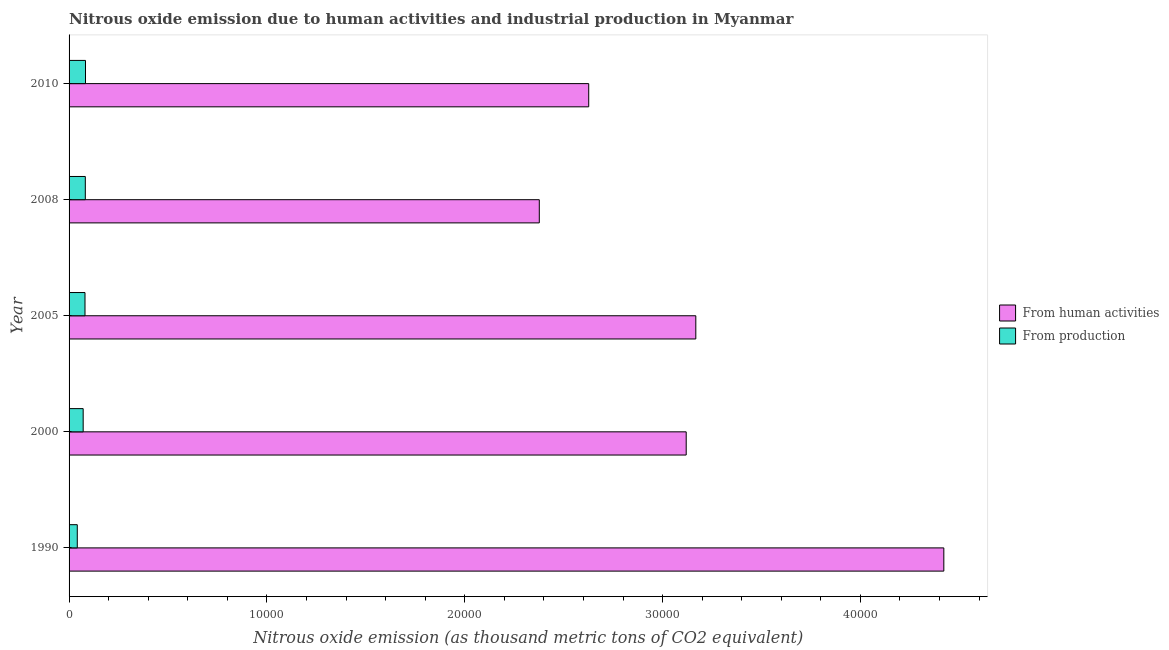Are the number of bars on each tick of the Y-axis equal?
Your response must be concise. Yes. How many bars are there on the 3rd tick from the top?
Offer a terse response. 2. How many bars are there on the 4th tick from the bottom?
Provide a succinct answer. 2. In how many cases, is the number of bars for a given year not equal to the number of legend labels?
Give a very brief answer. 0. What is the amount of emissions generated from industries in 2010?
Keep it short and to the point. 830.8. Across all years, what is the maximum amount of emissions generated from industries?
Your answer should be compact. 830.8. Across all years, what is the minimum amount of emissions from human activities?
Provide a succinct answer. 2.38e+04. What is the total amount of emissions from human activities in the graph?
Provide a succinct answer. 1.57e+05. What is the difference between the amount of emissions generated from industries in 2000 and that in 2010?
Your answer should be compact. -117.7. What is the difference between the amount of emissions generated from industries in 2000 and the amount of emissions from human activities in 2010?
Give a very brief answer. -2.56e+04. What is the average amount of emissions from human activities per year?
Keep it short and to the point. 3.14e+04. In the year 2008, what is the difference between the amount of emissions generated from industries and amount of emissions from human activities?
Make the answer very short. -2.29e+04. What is the ratio of the amount of emissions generated from industries in 1990 to that in 2008?
Provide a succinct answer. 0.51. Is the amount of emissions generated from industries in 2000 less than that in 2010?
Offer a terse response. Yes. What is the difference between the highest and the second highest amount of emissions from human activities?
Provide a short and direct response. 1.25e+04. What is the difference between the highest and the lowest amount of emissions from human activities?
Your answer should be very brief. 2.04e+04. In how many years, is the amount of emissions from human activities greater than the average amount of emissions from human activities taken over all years?
Ensure brevity in your answer.  2. What does the 2nd bar from the top in 2008 represents?
Your response must be concise. From human activities. What does the 2nd bar from the bottom in 2000 represents?
Offer a terse response. From production. How many bars are there?
Your answer should be compact. 10. Are all the bars in the graph horizontal?
Your answer should be very brief. Yes. How many years are there in the graph?
Your response must be concise. 5. What is the difference between two consecutive major ticks on the X-axis?
Make the answer very short. 10000. Does the graph contain grids?
Your answer should be compact. No. How many legend labels are there?
Provide a succinct answer. 2. How are the legend labels stacked?
Provide a succinct answer. Vertical. What is the title of the graph?
Provide a succinct answer. Nitrous oxide emission due to human activities and industrial production in Myanmar. What is the label or title of the X-axis?
Provide a short and direct response. Nitrous oxide emission (as thousand metric tons of CO2 equivalent). What is the label or title of the Y-axis?
Provide a succinct answer. Year. What is the Nitrous oxide emission (as thousand metric tons of CO2 equivalent) of From human activities in 1990?
Give a very brief answer. 4.42e+04. What is the Nitrous oxide emission (as thousand metric tons of CO2 equivalent) in From production in 1990?
Give a very brief answer. 414.7. What is the Nitrous oxide emission (as thousand metric tons of CO2 equivalent) in From human activities in 2000?
Give a very brief answer. 3.12e+04. What is the Nitrous oxide emission (as thousand metric tons of CO2 equivalent) in From production in 2000?
Offer a very short reply. 713.1. What is the Nitrous oxide emission (as thousand metric tons of CO2 equivalent) in From human activities in 2005?
Your answer should be compact. 3.17e+04. What is the Nitrous oxide emission (as thousand metric tons of CO2 equivalent) in From production in 2005?
Your response must be concise. 804.8. What is the Nitrous oxide emission (as thousand metric tons of CO2 equivalent) in From human activities in 2008?
Offer a very short reply. 2.38e+04. What is the Nitrous oxide emission (as thousand metric tons of CO2 equivalent) in From production in 2008?
Your answer should be very brief. 821.1. What is the Nitrous oxide emission (as thousand metric tons of CO2 equivalent) in From human activities in 2010?
Your answer should be compact. 2.63e+04. What is the Nitrous oxide emission (as thousand metric tons of CO2 equivalent) in From production in 2010?
Make the answer very short. 830.8. Across all years, what is the maximum Nitrous oxide emission (as thousand metric tons of CO2 equivalent) of From human activities?
Provide a succinct answer. 4.42e+04. Across all years, what is the maximum Nitrous oxide emission (as thousand metric tons of CO2 equivalent) of From production?
Give a very brief answer. 830.8. Across all years, what is the minimum Nitrous oxide emission (as thousand metric tons of CO2 equivalent) of From human activities?
Offer a terse response. 2.38e+04. Across all years, what is the minimum Nitrous oxide emission (as thousand metric tons of CO2 equivalent) of From production?
Ensure brevity in your answer.  414.7. What is the total Nitrous oxide emission (as thousand metric tons of CO2 equivalent) in From human activities in the graph?
Keep it short and to the point. 1.57e+05. What is the total Nitrous oxide emission (as thousand metric tons of CO2 equivalent) in From production in the graph?
Provide a succinct answer. 3584.5. What is the difference between the Nitrous oxide emission (as thousand metric tons of CO2 equivalent) of From human activities in 1990 and that in 2000?
Ensure brevity in your answer.  1.30e+04. What is the difference between the Nitrous oxide emission (as thousand metric tons of CO2 equivalent) in From production in 1990 and that in 2000?
Offer a very short reply. -298.4. What is the difference between the Nitrous oxide emission (as thousand metric tons of CO2 equivalent) in From human activities in 1990 and that in 2005?
Your answer should be very brief. 1.25e+04. What is the difference between the Nitrous oxide emission (as thousand metric tons of CO2 equivalent) in From production in 1990 and that in 2005?
Provide a succinct answer. -390.1. What is the difference between the Nitrous oxide emission (as thousand metric tons of CO2 equivalent) of From human activities in 1990 and that in 2008?
Ensure brevity in your answer.  2.04e+04. What is the difference between the Nitrous oxide emission (as thousand metric tons of CO2 equivalent) of From production in 1990 and that in 2008?
Give a very brief answer. -406.4. What is the difference between the Nitrous oxide emission (as thousand metric tons of CO2 equivalent) in From human activities in 1990 and that in 2010?
Offer a terse response. 1.80e+04. What is the difference between the Nitrous oxide emission (as thousand metric tons of CO2 equivalent) in From production in 1990 and that in 2010?
Ensure brevity in your answer.  -416.1. What is the difference between the Nitrous oxide emission (as thousand metric tons of CO2 equivalent) of From human activities in 2000 and that in 2005?
Make the answer very short. -485.9. What is the difference between the Nitrous oxide emission (as thousand metric tons of CO2 equivalent) of From production in 2000 and that in 2005?
Your response must be concise. -91.7. What is the difference between the Nitrous oxide emission (as thousand metric tons of CO2 equivalent) of From human activities in 2000 and that in 2008?
Your answer should be very brief. 7425.1. What is the difference between the Nitrous oxide emission (as thousand metric tons of CO2 equivalent) in From production in 2000 and that in 2008?
Give a very brief answer. -108. What is the difference between the Nitrous oxide emission (as thousand metric tons of CO2 equivalent) of From human activities in 2000 and that in 2010?
Your answer should be very brief. 4927.7. What is the difference between the Nitrous oxide emission (as thousand metric tons of CO2 equivalent) of From production in 2000 and that in 2010?
Your response must be concise. -117.7. What is the difference between the Nitrous oxide emission (as thousand metric tons of CO2 equivalent) in From human activities in 2005 and that in 2008?
Your response must be concise. 7911. What is the difference between the Nitrous oxide emission (as thousand metric tons of CO2 equivalent) of From production in 2005 and that in 2008?
Provide a succinct answer. -16.3. What is the difference between the Nitrous oxide emission (as thousand metric tons of CO2 equivalent) in From human activities in 2005 and that in 2010?
Your answer should be very brief. 5413.6. What is the difference between the Nitrous oxide emission (as thousand metric tons of CO2 equivalent) in From production in 2005 and that in 2010?
Give a very brief answer. -26. What is the difference between the Nitrous oxide emission (as thousand metric tons of CO2 equivalent) in From human activities in 2008 and that in 2010?
Your answer should be very brief. -2497.4. What is the difference between the Nitrous oxide emission (as thousand metric tons of CO2 equivalent) in From production in 2008 and that in 2010?
Provide a short and direct response. -9.7. What is the difference between the Nitrous oxide emission (as thousand metric tons of CO2 equivalent) in From human activities in 1990 and the Nitrous oxide emission (as thousand metric tons of CO2 equivalent) in From production in 2000?
Your response must be concise. 4.35e+04. What is the difference between the Nitrous oxide emission (as thousand metric tons of CO2 equivalent) of From human activities in 1990 and the Nitrous oxide emission (as thousand metric tons of CO2 equivalent) of From production in 2005?
Ensure brevity in your answer.  4.34e+04. What is the difference between the Nitrous oxide emission (as thousand metric tons of CO2 equivalent) of From human activities in 1990 and the Nitrous oxide emission (as thousand metric tons of CO2 equivalent) of From production in 2008?
Keep it short and to the point. 4.34e+04. What is the difference between the Nitrous oxide emission (as thousand metric tons of CO2 equivalent) in From human activities in 1990 and the Nitrous oxide emission (as thousand metric tons of CO2 equivalent) in From production in 2010?
Make the answer very short. 4.34e+04. What is the difference between the Nitrous oxide emission (as thousand metric tons of CO2 equivalent) of From human activities in 2000 and the Nitrous oxide emission (as thousand metric tons of CO2 equivalent) of From production in 2005?
Ensure brevity in your answer.  3.04e+04. What is the difference between the Nitrous oxide emission (as thousand metric tons of CO2 equivalent) of From human activities in 2000 and the Nitrous oxide emission (as thousand metric tons of CO2 equivalent) of From production in 2008?
Ensure brevity in your answer.  3.04e+04. What is the difference between the Nitrous oxide emission (as thousand metric tons of CO2 equivalent) in From human activities in 2000 and the Nitrous oxide emission (as thousand metric tons of CO2 equivalent) in From production in 2010?
Provide a succinct answer. 3.04e+04. What is the difference between the Nitrous oxide emission (as thousand metric tons of CO2 equivalent) of From human activities in 2005 and the Nitrous oxide emission (as thousand metric tons of CO2 equivalent) of From production in 2008?
Offer a very short reply. 3.09e+04. What is the difference between the Nitrous oxide emission (as thousand metric tons of CO2 equivalent) of From human activities in 2005 and the Nitrous oxide emission (as thousand metric tons of CO2 equivalent) of From production in 2010?
Provide a short and direct response. 3.08e+04. What is the difference between the Nitrous oxide emission (as thousand metric tons of CO2 equivalent) in From human activities in 2008 and the Nitrous oxide emission (as thousand metric tons of CO2 equivalent) in From production in 2010?
Ensure brevity in your answer.  2.29e+04. What is the average Nitrous oxide emission (as thousand metric tons of CO2 equivalent) of From human activities per year?
Your response must be concise. 3.14e+04. What is the average Nitrous oxide emission (as thousand metric tons of CO2 equivalent) in From production per year?
Your response must be concise. 716.9. In the year 1990, what is the difference between the Nitrous oxide emission (as thousand metric tons of CO2 equivalent) of From human activities and Nitrous oxide emission (as thousand metric tons of CO2 equivalent) of From production?
Make the answer very short. 4.38e+04. In the year 2000, what is the difference between the Nitrous oxide emission (as thousand metric tons of CO2 equivalent) in From human activities and Nitrous oxide emission (as thousand metric tons of CO2 equivalent) in From production?
Your answer should be compact. 3.05e+04. In the year 2005, what is the difference between the Nitrous oxide emission (as thousand metric tons of CO2 equivalent) of From human activities and Nitrous oxide emission (as thousand metric tons of CO2 equivalent) of From production?
Keep it short and to the point. 3.09e+04. In the year 2008, what is the difference between the Nitrous oxide emission (as thousand metric tons of CO2 equivalent) of From human activities and Nitrous oxide emission (as thousand metric tons of CO2 equivalent) of From production?
Offer a terse response. 2.29e+04. In the year 2010, what is the difference between the Nitrous oxide emission (as thousand metric tons of CO2 equivalent) of From human activities and Nitrous oxide emission (as thousand metric tons of CO2 equivalent) of From production?
Your answer should be compact. 2.54e+04. What is the ratio of the Nitrous oxide emission (as thousand metric tons of CO2 equivalent) in From human activities in 1990 to that in 2000?
Keep it short and to the point. 1.42. What is the ratio of the Nitrous oxide emission (as thousand metric tons of CO2 equivalent) in From production in 1990 to that in 2000?
Offer a very short reply. 0.58. What is the ratio of the Nitrous oxide emission (as thousand metric tons of CO2 equivalent) of From human activities in 1990 to that in 2005?
Your response must be concise. 1.4. What is the ratio of the Nitrous oxide emission (as thousand metric tons of CO2 equivalent) in From production in 1990 to that in 2005?
Your answer should be very brief. 0.52. What is the ratio of the Nitrous oxide emission (as thousand metric tons of CO2 equivalent) in From human activities in 1990 to that in 2008?
Make the answer very short. 1.86. What is the ratio of the Nitrous oxide emission (as thousand metric tons of CO2 equivalent) of From production in 1990 to that in 2008?
Keep it short and to the point. 0.51. What is the ratio of the Nitrous oxide emission (as thousand metric tons of CO2 equivalent) of From human activities in 1990 to that in 2010?
Make the answer very short. 1.68. What is the ratio of the Nitrous oxide emission (as thousand metric tons of CO2 equivalent) of From production in 1990 to that in 2010?
Your response must be concise. 0.5. What is the ratio of the Nitrous oxide emission (as thousand metric tons of CO2 equivalent) of From human activities in 2000 to that in 2005?
Offer a terse response. 0.98. What is the ratio of the Nitrous oxide emission (as thousand metric tons of CO2 equivalent) in From production in 2000 to that in 2005?
Give a very brief answer. 0.89. What is the ratio of the Nitrous oxide emission (as thousand metric tons of CO2 equivalent) of From human activities in 2000 to that in 2008?
Make the answer very short. 1.31. What is the ratio of the Nitrous oxide emission (as thousand metric tons of CO2 equivalent) of From production in 2000 to that in 2008?
Your answer should be very brief. 0.87. What is the ratio of the Nitrous oxide emission (as thousand metric tons of CO2 equivalent) of From human activities in 2000 to that in 2010?
Offer a terse response. 1.19. What is the ratio of the Nitrous oxide emission (as thousand metric tons of CO2 equivalent) of From production in 2000 to that in 2010?
Provide a succinct answer. 0.86. What is the ratio of the Nitrous oxide emission (as thousand metric tons of CO2 equivalent) in From human activities in 2005 to that in 2008?
Your answer should be very brief. 1.33. What is the ratio of the Nitrous oxide emission (as thousand metric tons of CO2 equivalent) of From production in 2005 to that in 2008?
Your answer should be very brief. 0.98. What is the ratio of the Nitrous oxide emission (as thousand metric tons of CO2 equivalent) in From human activities in 2005 to that in 2010?
Make the answer very short. 1.21. What is the ratio of the Nitrous oxide emission (as thousand metric tons of CO2 equivalent) in From production in 2005 to that in 2010?
Give a very brief answer. 0.97. What is the ratio of the Nitrous oxide emission (as thousand metric tons of CO2 equivalent) of From human activities in 2008 to that in 2010?
Your response must be concise. 0.9. What is the ratio of the Nitrous oxide emission (as thousand metric tons of CO2 equivalent) in From production in 2008 to that in 2010?
Your response must be concise. 0.99. What is the difference between the highest and the second highest Nitrous oxide emission (as thousand metric tons of CO2 equivalent) in From human activities?
Make the answer very short. 1.25e+04. What is the difference between the highest and the second highest Nitrous oxide emission (as thousand metric tons of CO2 equivalent) in From production?
Your answer should be compact. 9.7. What is the difference between the highest and the lowest Nitrous oxide emission (as thousand metric tons of CO2 equivalent) in From human activities?
Ensure brevity in your answer.  2.04e+04. What is the difference between the highest and the lowest Nitrous oxide emission (as thousand metric tons of CO2 equivalent) of From production?
Keep it short and to the point. 416.1. 